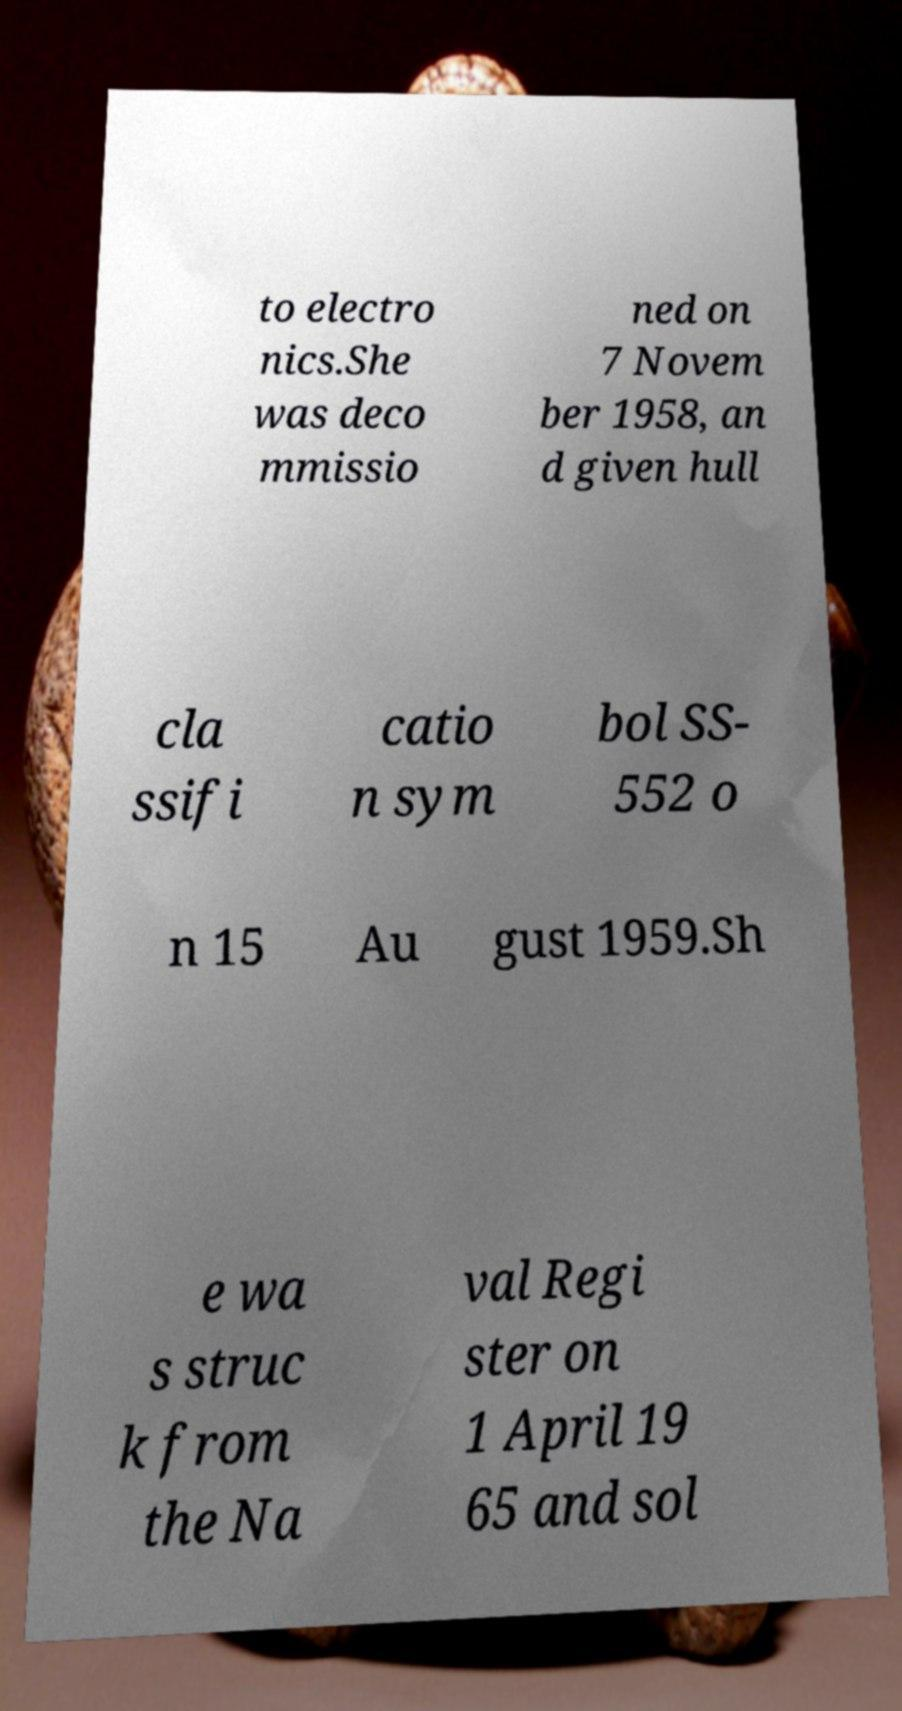Could you assist in decoding the text presented in this image and type it out clearly? to electro nics.She was deco mmissio ned on 7 Novem ber 1958, an d given hull cla ssifi catio n sym bol SS- 552 o n 15 Au gust 1959.Sh e wa s struc k from the Na val Regi ster on 1 April 19 65 and sol 